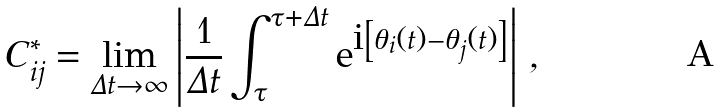<formula> <loc_0><loc_0><loc_500><loc_500>C ^ { * } _ { i j } = \lim _ { \Delta t \rightarrow \infty } \left | \frac { 1 } { \Delta t } \int _ { \tau } ^ { \tau + \Delta t } { \mbox e } ^ { { \mbox i } \left [ \theta _ { i } ( t ) - \theta _ { j } ( t ) \right ] } \right | \, ,</formula> 